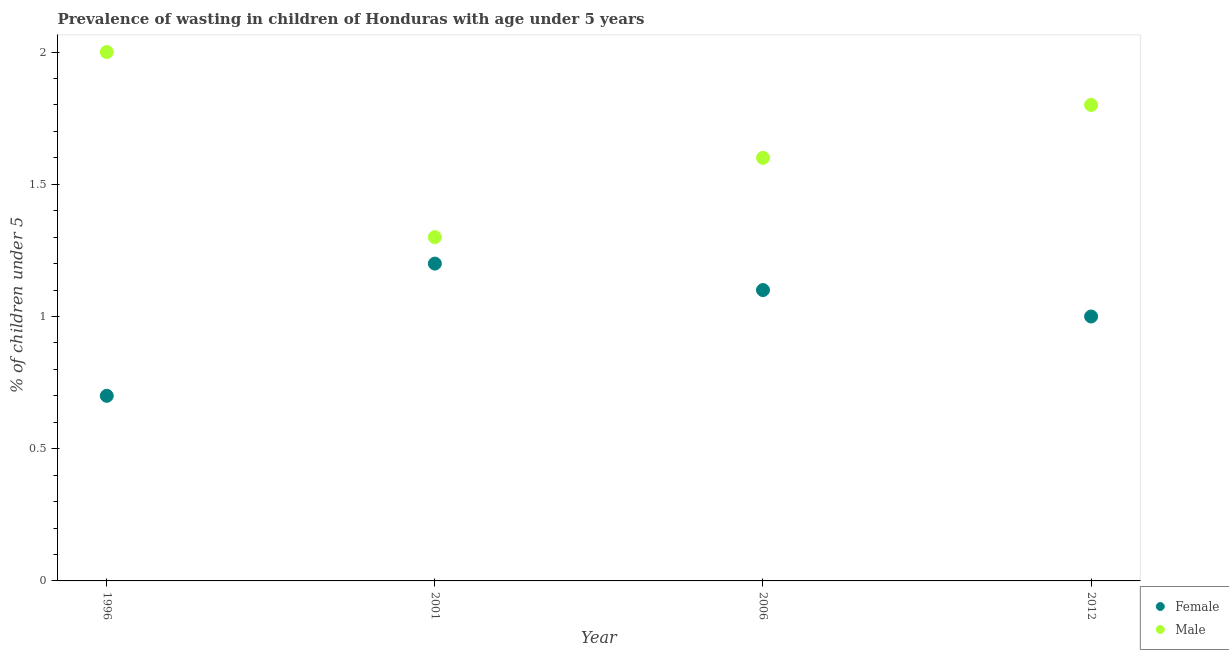How many different coloured dotlines are there?
Offer a very short reply. 2. Is the number of dotlines equal to the number of legend labels?
Make the answer very short. Yes. What is the percentage of undernourished male children in 2012?
Offer a terse response. 1.8. Across all years, what is the maximum percentage of undernourished female children?
Provide a short and direct response. 1.2. Across all years, what is the minimum percentage of undernourished female children?
Your answer should be compact. 0.7. In which year was the percentage of undernourished male children maximum?
Offer a very short reply. 1996. What is the total percentage of undernourished male children in the graph?
Offer a very short reply. 6.7. What is the difference between the percentage of undernourished male children in 1996 and that in 2001?
Your answer should be compact. 0.7. What is the difference between the percentage of undernourished male children in 2006 and the percentage of undernourished female children in 1996?
Your answer should be very brief. 0.9. What is the average percentage of undernourished male children per year?
Keep it short and to the point. 1.67. In the year 2006, what is the difference between the percentage of undernourished male children and percentage of undernourished female children?
Make the answer very short. 0.5. In how many years, is the percentage of undernourished male children greater than 0.2 %?
Make the answer very short. 4. What is the ratio of the percentage of undernourished female children in 2006 to that in 2012?
Offer a very short reply. 1.1. Is the percentage of undernourished male children in 1996 less than that in 2012?
Offer a terse response. No. What is the difference between the highest and the second highest percentage of undernourished male children?
Your response must be concise. 0.2. What is the difference between the highest and the lowest percentage of undernourished male children?
Your answer should be compact. 0.7. Is the sum of the percentage of undernourished female children in 2006 and 2012 greater than the maximum percentage of undernourished male children across all years?
Ensure brevity in your answer.  Yes. Is the percentage of undernourished male children strictly greater than the percentage of undernourished female children over the years?
Offer a very short reply. Yes. What is the difference between two consecutive major ticks on the Y-axis?
Your response must be concise. 0.5. Does the graph contain any zero values?
Your answer should be very brief. No. Does the graph contain grids?
Your answer should be compact. No. Where does the legend appear in the graph?
Provide a short and direct response. Bottom right. How many legend labels are there?
Keep it short and to the point. 2. How are the legend labels stacked?
Your response must be concise. Vertical. What is the title of the graph?
Make the answer very short. Prevalence of wasting in children of Honduras with age under 5 years. What is the label or title of the Y-axis?
Give a very brief answer.  % of children under 5. What is the  % of children under 5 of Female in 1996?
Your response must be concise. 0.7. What is the  % of children under 5 in Female in 2001?
Offer a very short reply. 1.2. What is the  % of children under 5 of Male in 2001?
Your answer should be very brief. 1.3. What is the  % of children under 5 in Female in 2006?
Give a very brief answer. 1.1. What is the  % of children under 5 in Male in 2006?
Offer a terse response. 1.6. What is the  % of children under 5 of Female in 2012?
Provide a succinct answer. 1. What is the  % of children under 5 in Male in 2012?
Offer a very short reply. 1.8. Across all years, what is the maximum  % of children under 5 of Female?
Offer a terse response. 1.2. Across all years, what is the minimum  % of children under 5 of Female?
Keep it short and to the point. 0.7. Across all years, what is the minimum  % of children under 5 in Male?
Provide a short and direct response. 1.3. What is the total  % of children under 5 in Female in the graph?
Your answer should be compact. 4. What is the total  % of children under 5 in Male in the graph?
Keep it short and to the point. 6.7. What is the difference between the  % of children under 5 of Female in 1996 and that in 2001?
Provide a succinct answer. -0.5. What is the difference between the  % of children under 5 in Male in 1996 and that in 2001?
Offer a very short reply. 0.7. What is the difference between the  % of children under 5 of Male in 1996 and that in 2006?
Offer a terse response. 0.4. What is the difference between the  % of children under 5 in Female in 1996 and that in 2012?
Your answer should be compact. -0.3. What is the difference between the  % of children under 5 in Male in 1996 and that in 2012?
Give a very brief answer. 0.2. What is the difference between the  % of children under 5 in Male in 2001 and that in 2012?
Your response must be concise. -0.5. What is the difference between the  % of children under 5 in Female in 2006 and that in 2012?
Provide a short and direct response. 0.1. What is the difference between the  % of children under 5 of Male in 2006 and that in 2012?
Give a very brief answer. -0.2. What is the difference between the  % of children under 5 of Female in 1996 and the  % of children under 5 of Male in 2012?
Provide a succinct answer. -1.1. What is the difference between the  % of children under 5 of Female in 2001 and the  % of children under 5 of Male in 2006?
Make the answer very short. -0.4. What is the difference between the  % of children under 5 in Female in 2006 and the  % of children under 5 in Male in 2012?
Keep it short and to the point. -0.7. What is the average  % of children under 5 of Female per year?
Make the answer very short. 1. What is the average  % of children under 5 in Male per year?
Your response must be concise. 1.68. In the year 1996, what is the difference between the  % of children under 5 of Female and  % of children under 5 of Male?
Ensure brevity in your answer.  -1.3. In the year 2006, what is the difference between the  % of children under 5 of Female and  % of children under 5 of Male?
Ensure brevity in your answer.  -0.5. What is the ratio of the  % of children under 5 in Female in 1996 to that in 2001?
Your answer should be compact. 0.58. What is the ratio of the  % of children under 5 of Male in 1996 to that in 2001?
Ensure brevity in your answer.  1.54. What is the ratio of the  % of children under 5 in Female in 1996 to that in 2006?
Make the answer very short. 0.64. What is the ratio of the  % of children under 5 in Female in 2001 to that in 2006?
Your answer should be very brief. 1.09. What is the ratio of the  % of children under 5 of Male in 2001 to that in 2006?
Your response must be concise. 0.81. What is the ratio of the  % of children under 5 of Male in 2001 to that in 2012?
Provide a short and direct response. 0.72. What is the ratio of the  % of children under 5 in Female in 2006 to that in 2012?
Make the answer very short. 1.1. What is the ratio of the  % of children under 5 of Male in 2006 to that in 2012?
Keep it short and to the point. 0.89. What is the difference between the highest and the second highest  % of children under 5 of Female?
Ensure brevity in your answer.  0.1. What is the difference between the highest and the second highest  % of children under 5 of Male?
Your response must be concise. 0.2. What is the difference between the highest and the lowest  % of children under 5 in Female?
Your response must be concise. 0.5. 